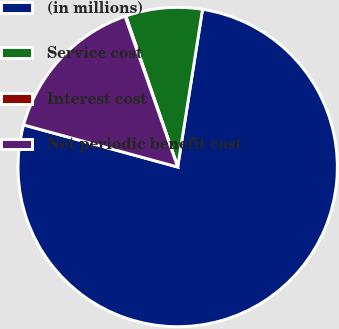Convert chart to OTSL. <chart><loc_0><loc_0><loc_500><loc_500><pie_chart><fcel>(in millions)<fcel>Service cost<fcel>Interest cost<fcel>Net periodic benefit cost<nl><fcel>76.76%<fcel>7.75%<fcel>0.08%<fcel>15.41%<nl></chart> 